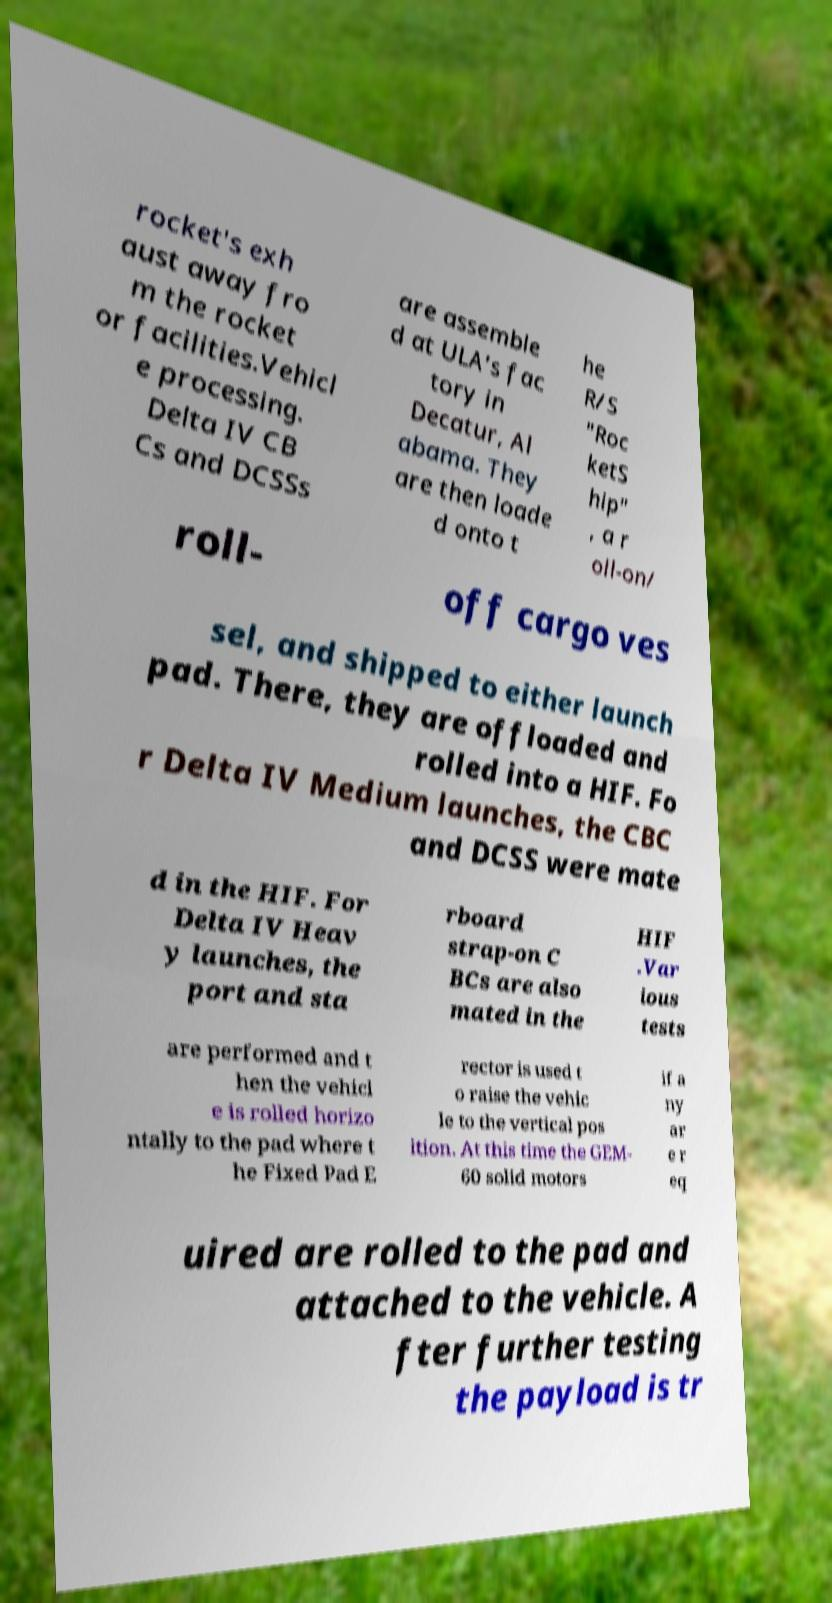Could you assist in decoding the text presented in this image and type it out clearly? rocket's exh aust away fro m the rocket or facilities.Vehicl e processing. Delta IV CB Cs and DCSSs are assemble d at ULA's fac tory in Decatur, Al abama. They are then loade d onto t he R/S "Roc ketS hip" , a r oll-on/ roll- off cargo ves sel, and shipped to either launch pad. There, they are offloaded and rolled into a HIF. Fo r Delta IV Medium launches, the CBC and DCSS were mate d in the HIF. For Delta IV Heav y launches, the port and sta rboard strap-on C BCs are also mated in the HIF .Var ious tests are performed and t hen the vehicl e is rolled horizo ntally to the pad where t he Fixed Pad E rector is used t o raise the vehic le to the vertical pos ition. At this time the GEM- 60 solid motors if a ny ar e r eq uired are rolled to the pad and attached to the vehicle. A fter further testing the payload is tr 